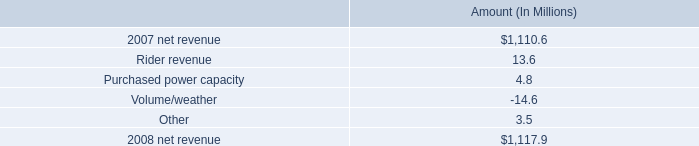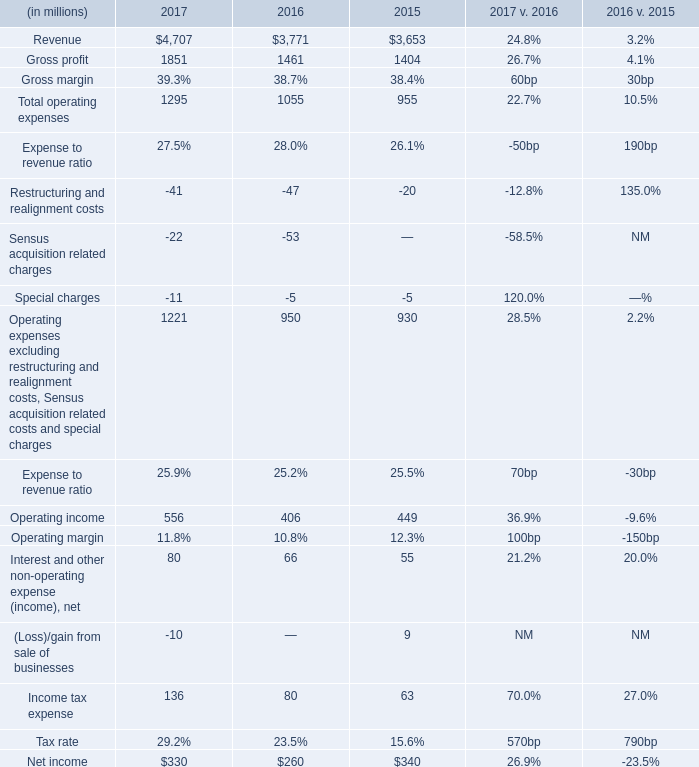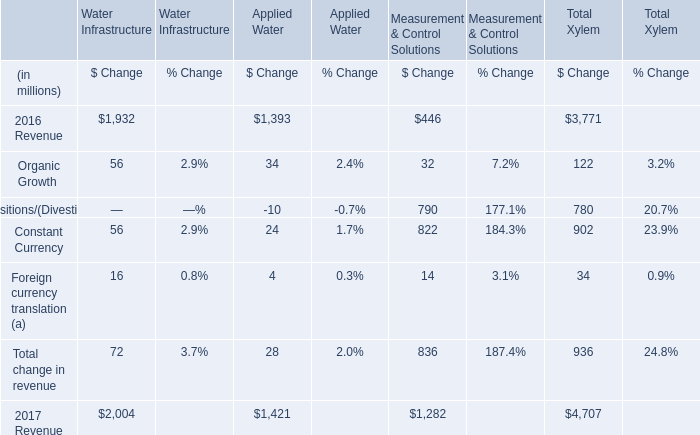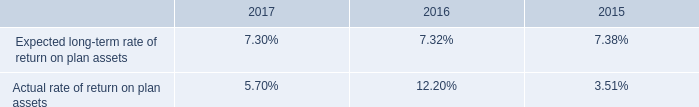what percent of the net change in revenue between 2007 and 2008 was due to rider revenue? 
Computations: (13.6 / (1110.6 - 1117.9))
Answer: -1.86301. 